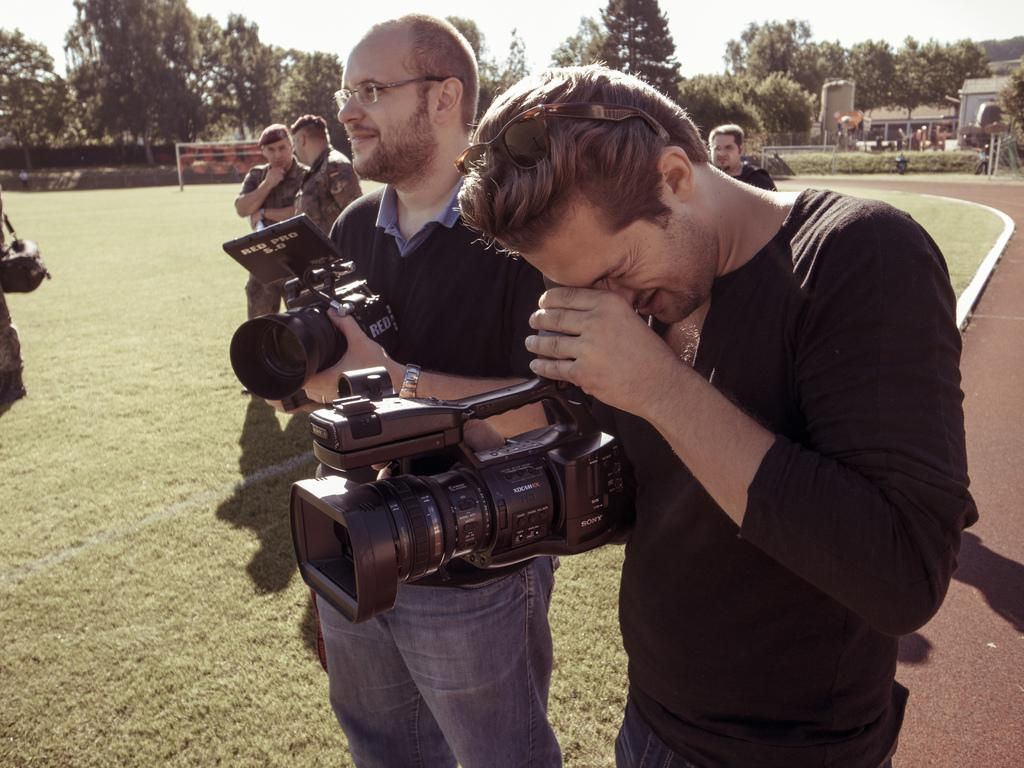How many people are in the image? There are 2 men in the image. What are the men doing in the image? The men are recording with a camera. Can you describe the background of the image? There are people visible in the background, along with trees, the sky, and a building. What type of clam can be seen in the image? There is no clam present in the image. Can you describe the ocean in the image? There is no ocean present in the image. 